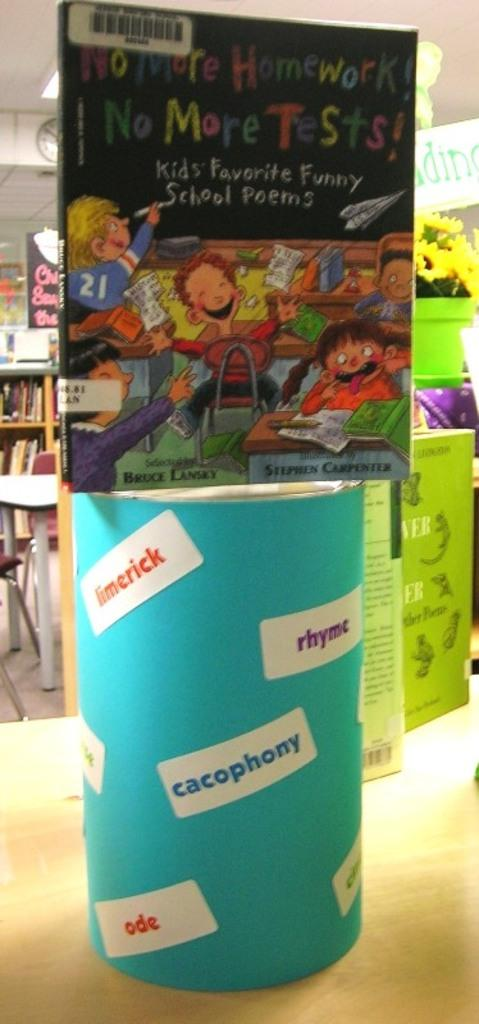<image>
Give a short and clear explanation of the subsequent image. A book is on top of a cylinder container with the words ode, rhyme, and others on it. 